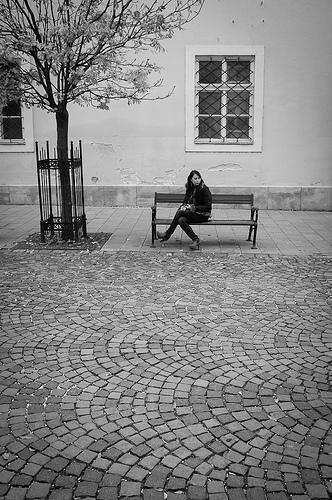Question: how is the woman positioned?
Choices:
A. Lying down.
B. Her legs straight.
C. Her left arm up.
D. With her legs crossed.
Answer with the letter. Answer: D Question: who is on the bench?
Choices:
A. A woman.
B. A man.
C. A girl.
D. A boy.
Answer with the letter. Answer: A Question: what is behind the woman?
Choices:
A. A tree.
B. A building.
C. A fountain.
D. An animal.
Answer with the letter. Answer: B Question: what is around the trunk of the tree?
Choices:
A. A fence.
B. Flowers.
C. A cage.
D. Dirt.
Answer with the letter. Answer: C Question: what is to the woman's right?
Choices:
A. A tree.
B. A boy.
C. A light pole.
D. A mailbox.
Answer with the letter. Answer: A 